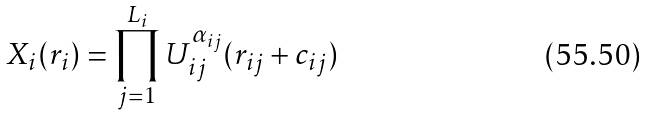Convert formula to latex. <formula><loc_0><loc_0><loc_500><loc_500>X _ { i } ( r _ { i } ) = \prod _ { j = 1 } ^ { L _ { i } } U _ { i j } ^ { \alpha _ { i j } } ( r _ { i j } + c _ { i j } )</formula> 